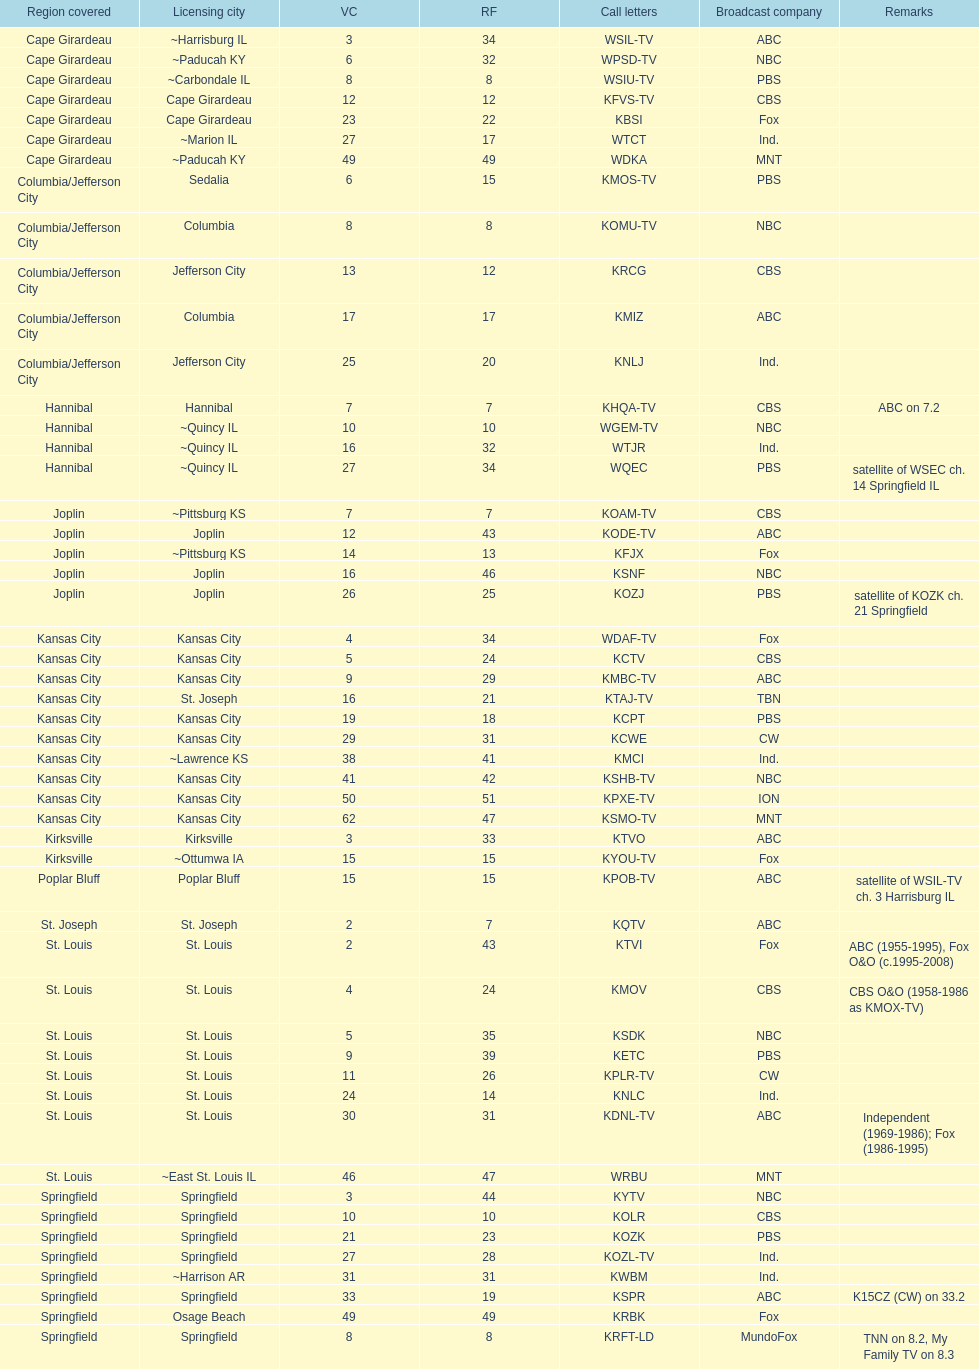How many television stations serve the cape girardeau area? 7. 